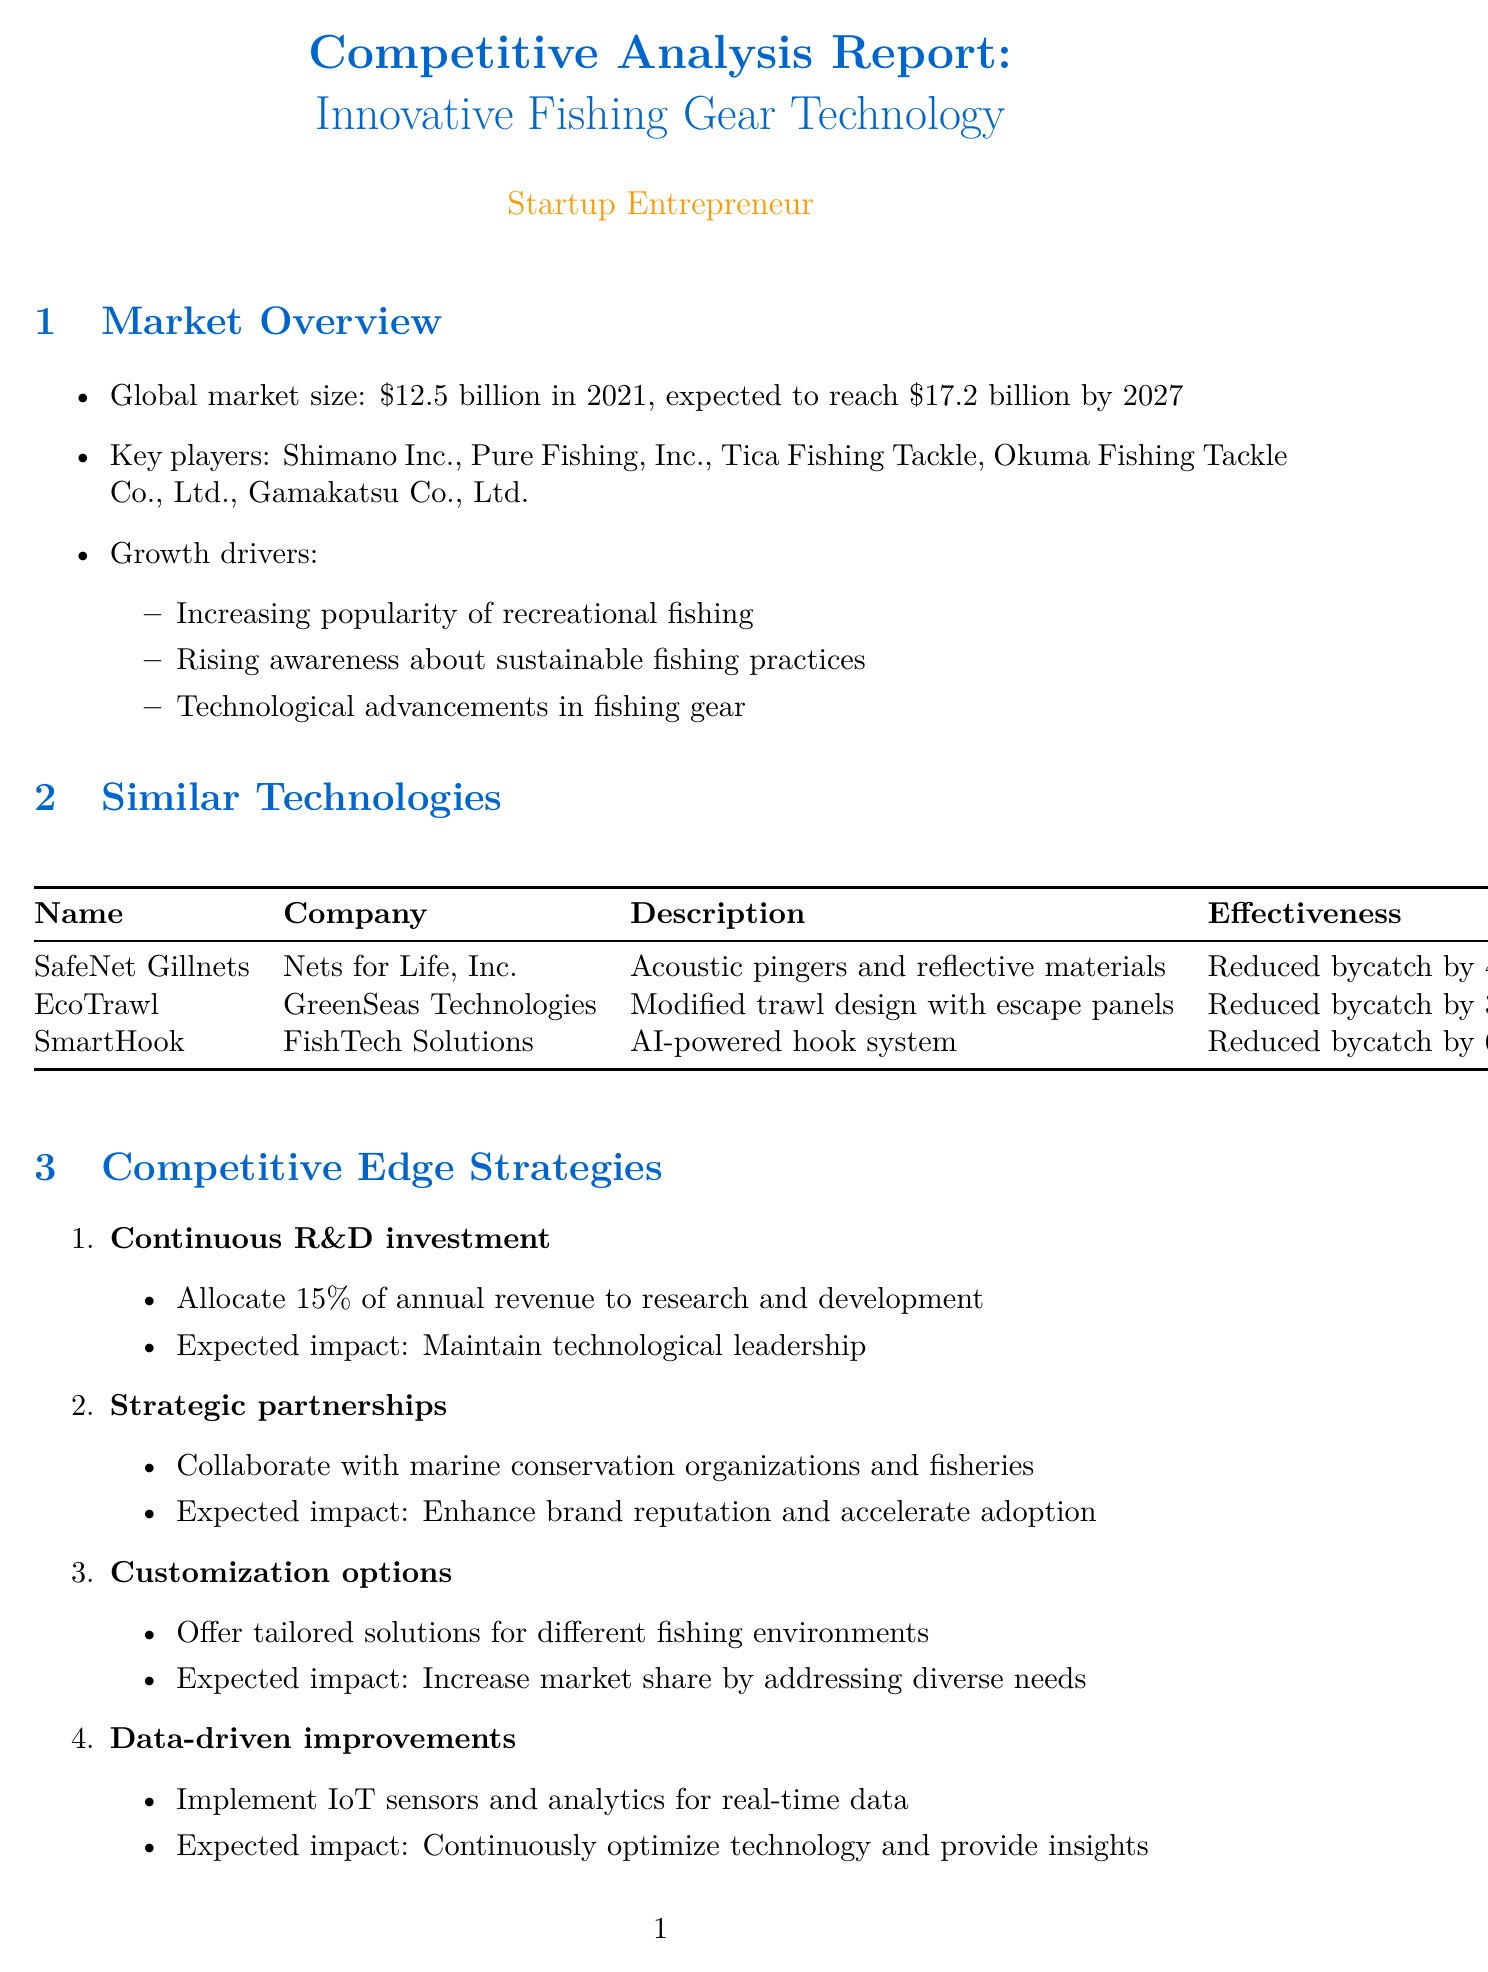what is the global market size in 2021? The document states that the global market size is $12.5 billion in 2021.
Answer: $12.5 billion who is the company behind SmartHook? The document lists FishTech Solutions as the company behind SmartHook.
Answer: FishTech Solutions what technology does EcoTrawl utilize? The description indicates that EcoTrawl uses a modified trawl design with escape panels for juvenile fish.
Answer: modified trawl design with escape panels what is one of the growth drivers in the fishing gear market? The report lists "Rising awareness about sustainable fishing practices" as a growth driver.
Answer: Rising awareness about sustainable fishing practices how much of the commercial gillnet market does SafeNet Gillnets control? The document states that SafeNet Gillnets has an 8% market share in the commercial gillnet market.
Answer: 8% what is a strategy for maintaining a competitive edge mentioned in the document? The document mentions "Continuous R&D investment" as one of the strategies for maintaining a competitive edge.
Answer: Continuous R&D investment how much of annual revenue should be allocated to R&D according to the competitive edge strategy? The document states that 15% of annual revenue should be allocated to research and development.
Answer: 15% name one key regulation impacting the fishing gear market. The document lists the Magnuson-Stevens Fishery Conservation and Management Act (USA) as one key regulation.
Answer: Magnuson-Stevens Fishery Conservation and Management Act (USA) what is the expected impact of strategic partnerships? The report states that the expected impact of strategic partnerships is to enhance brand reputation and accelerate product adoption.
Answer: Enhance brand reputation and accelerate product adoption 